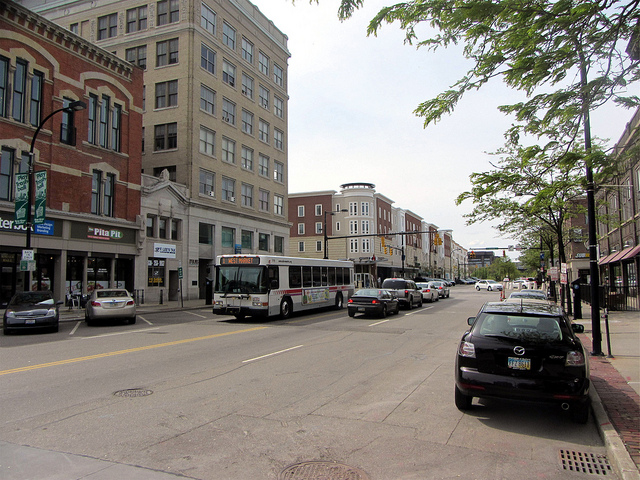<image>Where is the street located in? I don't know where the street is located. It could be in London, Champaign IL, New York, or somewhere in America. What is the number of this platform? It is ambiguous what the number of the platform is. It's possible there is no number displayed. What is the name on the building? I cannot definitively say what the name on the building is. It could be 'pita pit', 'bank', 'sears', or 'otterbox'. Where is the street located in? I don't know where the street is located in. It can be London, Champaign IL, or New York. What is the number of this platform? The number of this platform is unknown. It can be either 100, 2, 12, 0, 60 or there may be no number. What is the name on the building? I don't know the name on the building. It can be 'pita pit', 'bank', 'sears' or 'otterbox'. 